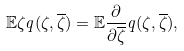<formula> <loc_0><loc_0><loc_500><loc_500>\mathbb { E } \zeta q ( \zeta , \overline { \zeta } ) = \mathbb { E } \frac { \partial } { \partial \overline { \zeta } } q ( \zeta , \overline { \zeta } ) ,</formula> 